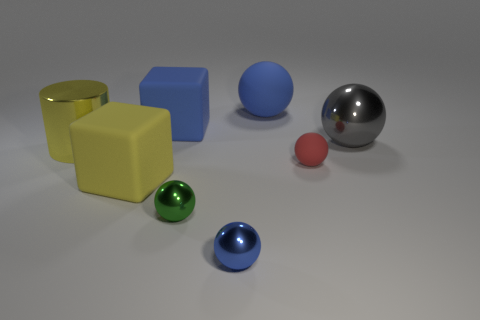Subtract all large matte balls. How many balls are left? 4 Subtract 1 cylinders. How many cylinders are left? 0 Subtract all blue blocks. How many blocks are left? 1 Add 2 big spheres. How many objects exist? 10 Subtract all gray blocks. Subtract all purple cylinders. How many blocks are left? 2 Subtract all green cylinders. How many purple balls are left? 0 Subtract 1 blue balls. How many objects are left? 7 Subtract all balls. How many objects are left? 3 Subtract all tiny red objects. Subtract all gray objects. How many objects are left? 6 Add 5 large rubber things. How many large rubber things are left? 8 